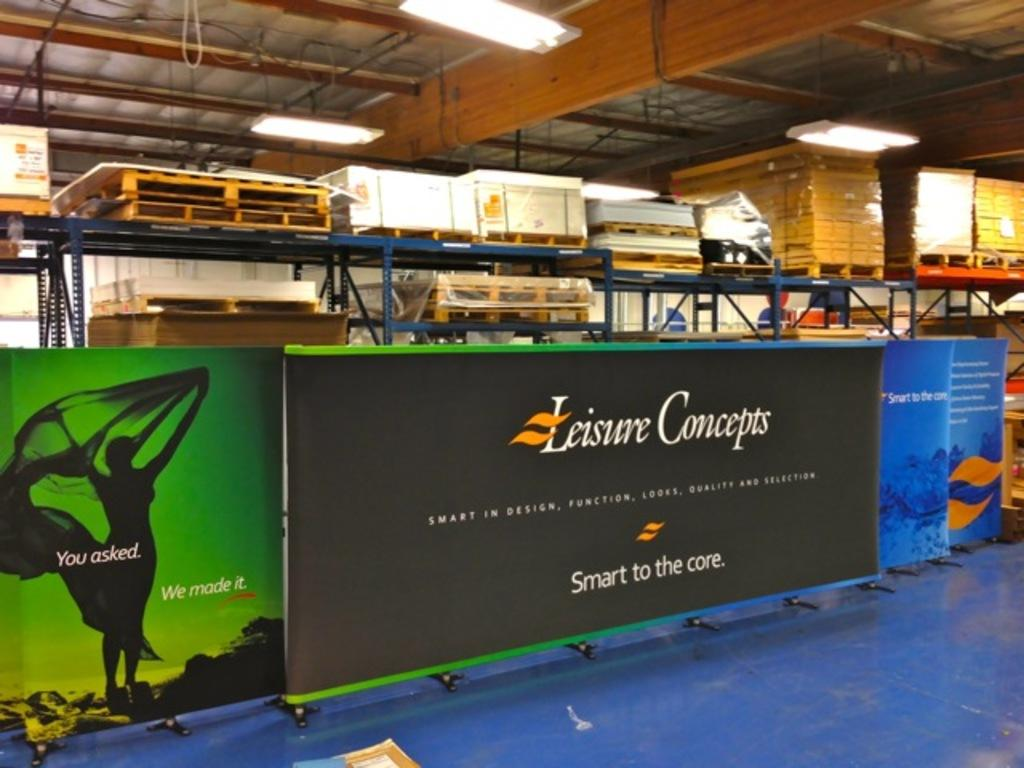Provide a one-sentence caption for the provided image. A billboard with Leisure concepts on top and smart to the core underneath. 